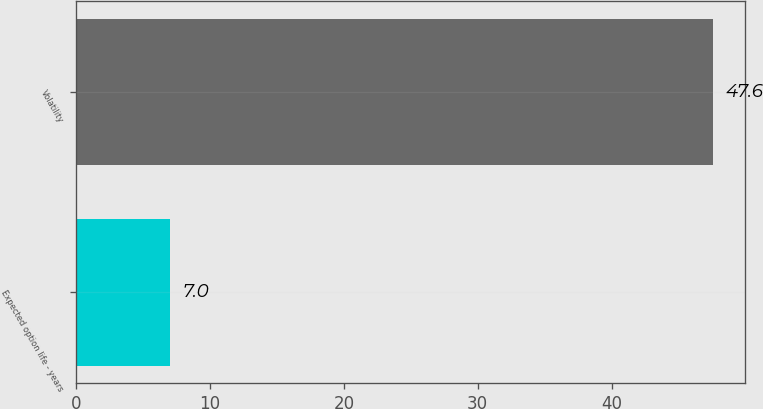Convert chart. <chart><loc_0><loc_0><loc_500><loc_500><bar_chart><fcel>Expected option life - years<fcel>Volatility<nl><fcel>7<fcel>47.6<nl></chart> 